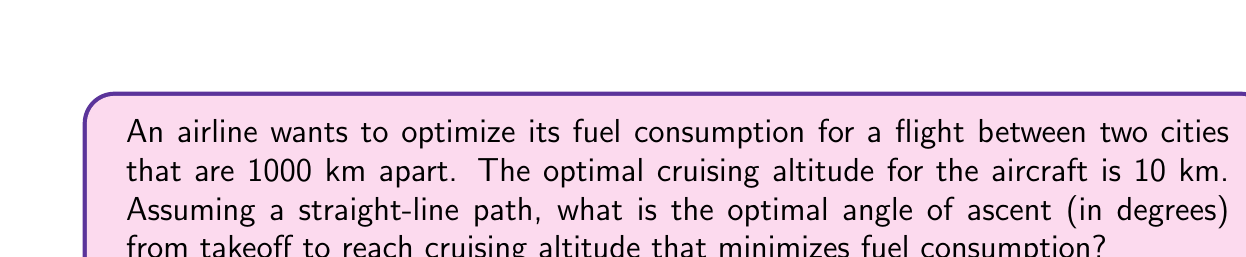Could you help me with this problem? To solve this problem, we need to consider the triangle formed by the flight path, the ground, and the vertical ascent to cruising altitude. We can use trigonometry to find the optimal angle.

1. Let's define our variables:
   $\theta$ = angle of ascent
   $a$ = altitude = 10 km
   $d$ = distance between cities = 1000 km

2. We can use the tangent function to relate the angle to the altitude and distance:

   $$\tan(\theta) = \frac{\text{opposite}}{\text{adjacent}} = \frac{a}{x}$$

   where $x$ is the horizontal distance covered during ascent.

3. The total distance is 1000 km, so:

   $$1000 - x = \sqrt{x^2 + a^2}$$

   This is because the hypotenuse of the right triangle formed after reaching cruising altitude must be equal to the remaining distance.

4. Solving for $x$:

   $$1000 - x = \sqrt{x^2 + 100}$$
   $$(1000 - x)^2 = x^2 + 100$$
   $$1,000,000 - 2000x + x^2 = x^2 + 100$$
   $$999,900 = 2000x$$
   $$x = 499.95 \text{ km}$$

5. Now we can calculate $\theta$:

   $$\theta = \arctan(\frac{a}{x}) = \arctan(\frac{10}{499.95})$$

6. Converting to degrees:

   $$\theta = \arctan(\frac{10}{499.95}) \cdot \frac{180}{\pi}$$

[asy]
import geometry;

size(200);
pair A=(0,0), B=(10,0), C=(10,2);
draw(A--B--C--A);
label("1000 km", B, S);
label("10 km", C, E);
label("$\theta$", A, NE);
[/asy]
Answer: $\theta \approx 1.15°$ 